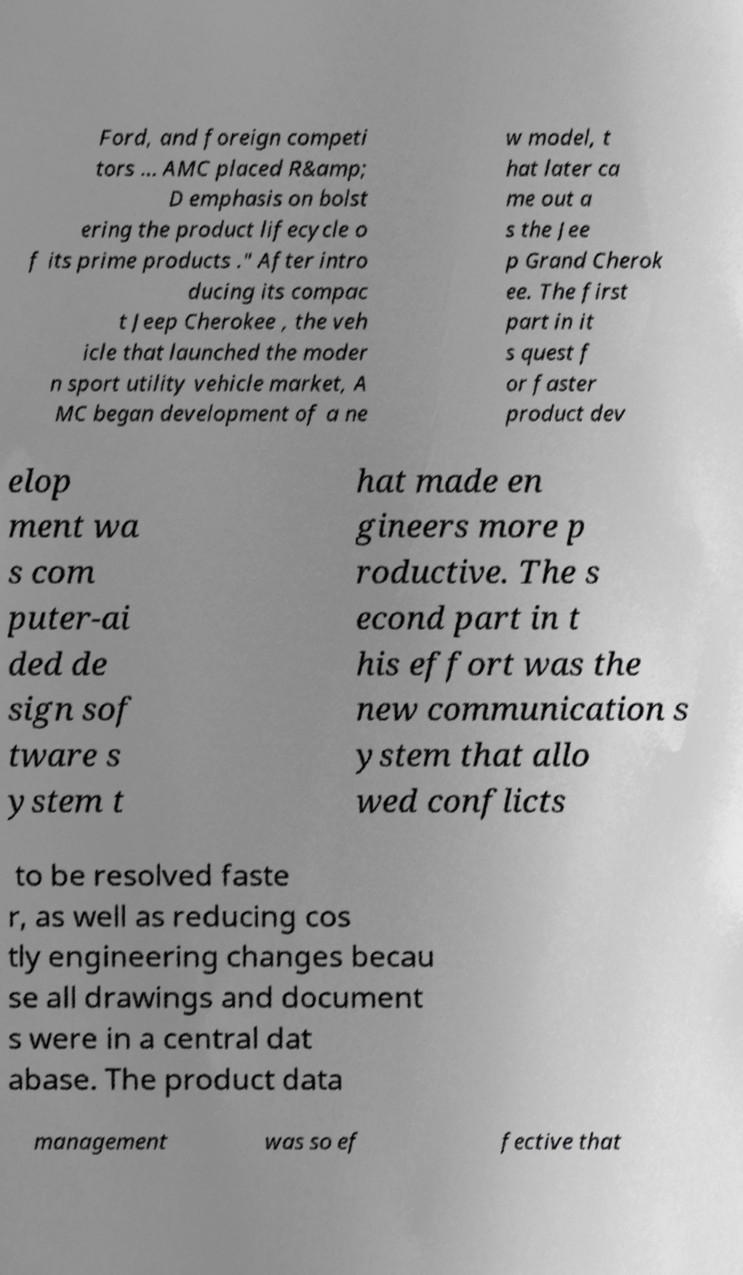For documentation purposes, I need the text within this image transcribed. Could you provide that? Ford, and foreign competi tors … AMC placed R&amp; D emphasis on bolst ering the product lifecycle o f its prime products ." After intro ducing its compac t Jeep Cherokee , the veh icle that launched the moder n sport utility vehicle market, A MC began development of a ne w model, t hat later ca me out a s the Jee p Grand Cherok ee. The first part in it s quest f or faster product dev elop ment wa s com puter-ai ded de sign sof tware s ystem t hat made en gineers more p roductive. The s econd part in t his effort was the new communication s ystem that allo wed conflicts to be resolved faste r, as well as reducing cos tly engineering changes becau se all drawings and document s were in a central dat abase. The product data management was so ef fective that 